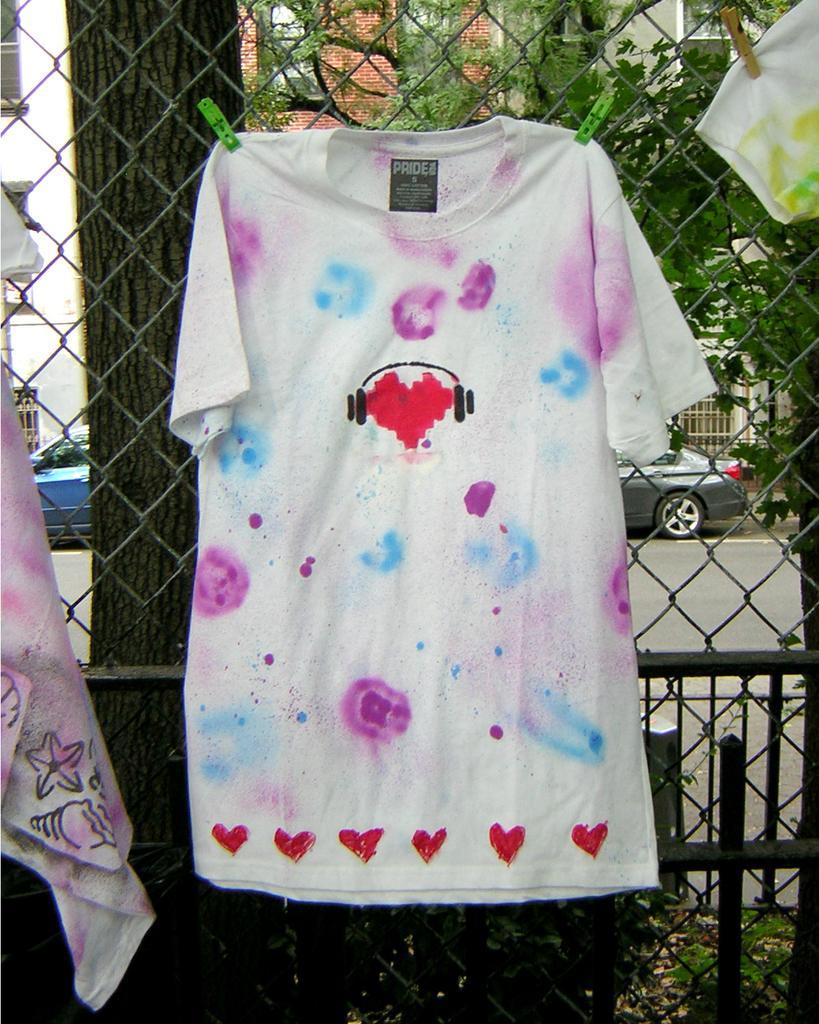How would you summarize this image in a sentence or two? In this image we can see there are few clothes hanging on a net fence with the help of clips, behind that there are trees, few vehicles on the road and buildings. 